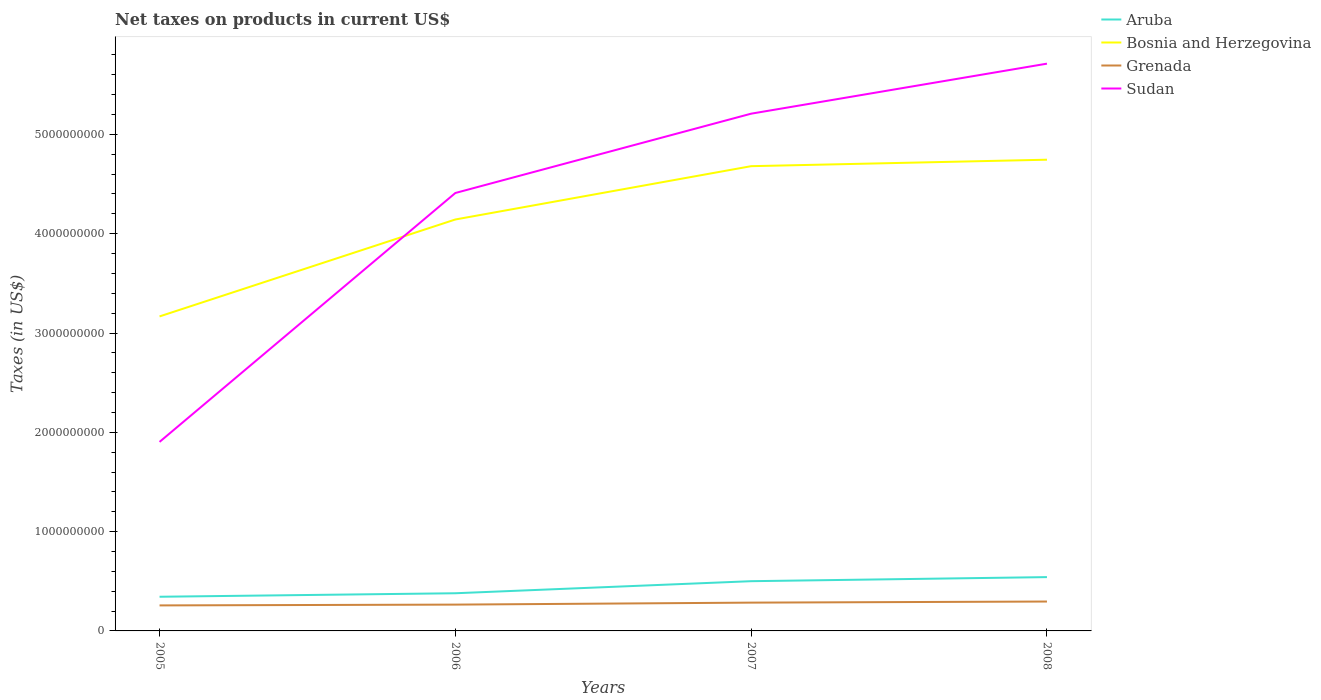Across all years, what is the maximum net taxes on products in Sudan?
Keep it short and to the point. 1.90e+09. What is the total net taxes on products in Grenada in the graph?
Give a very brief answer. -3.91e+07. What is the difference between the highest and the second highest net taxes on products in Bosnia and Herzegovina?
Make the answer very short. 1.58e+09. What is the difference between the highest and the lowest net taxes on products in Grenada?
Your response must be concise. 2. How many lines are there?
Offer a terse response. 4. How many years are there in the graph?
Make the answer very short. 4. What is the difference between two consecutive major ticks on the Y-axis?
Provide a short and direct response. 1.00e+09. Are the values on the major ticks of Y-axis written in scientific E-notation?
Give a very brief answer. No. Does the graph contain grids?
Ensure brevity in your answer.  No. Where does the legend appear in the graph?
Your answer should be very brief. Top right. How many legend labels are there?
Keep it short and to the point. 4. How are the legend labels stacked?
Offer a terse response. Vertical. What is the title of the graph?
Provide a succinct answer. Net taxes on products in current US$. Does "Sint Maarten (Dutch part)" appear as one of the legend labels in the graph?
Make the answer very short. No. What is the label or title of the Y-axis?
Keep it short and to the point. Taxes (in US$). What is the Taxes (in US$) in Aruba in 2005?
Provide a succinct answer. 3.44e+08. What is the Taxes (in US$) of Bosnia and Herzegovina in 2005?
Give a very brief answer. 3.17e+09. What is the Taxes (in US$) of Grenada in 2005?
Provide a short and direct response. 2.57e+08. What is the Taxes (in US$) in Sudan in 2005?
Keep it short and to the point. 1.90e+09. What is the Taxes (in US$) of Aruba in 2006?
Ensure brevity in your answer.  3.79e+08. What is the Taxes (in US$) of Bosnia and Herzegovina in 2006?
Your answer should be very brief. 4.14e+09. What is the Taxes (in US$) in Grenada in 2006?
Your answer should be very brief. 2.65e+08. What is the Taxes (in US$) in Sudan in 2006?
Offer a very short reply. 4.41e+09. What is the Taxes (in US$) of Aruba in 2007?
Offer a terse response. 5.01e+08. What is the Taxes (in US$) of Bosnia and Herzegovina in 2007?
Your answer should be very brief. 4.68e+09. What is the Taxes (in US$) in Grenada in 2007?
Your answer should be compact. 2.85e+08. What is the Taxes (in US$) in Sudan in 2007?
Make the answer very short. 5.21e+09. What is the Taxes (in US$) of Aruba in 2008?
Make the answer very short. 5.42e+08. What is the Taxes (in US$) in Bosnia and Herzegovina in 2008?
Provide a short and direct response. 4.75e+09. What is the Taxes (in US$) in Grenada in 2008?
Provide a short and direct response. 2.96e+08. What is the Taxes (in US$) in Sudan in 2008?
Provide a succinct answer. 5.71e+09. Across all years, what is the maximum Taxes (in US$) of Aruba?
Give a very brief answer. 5.42e+08. Across all years, what is the maximum Taxes (in US$) of Bosnia and Herzegovina?
Offer a terse response. 4.75e+09. Across all years, what is the maximum Taxes (in US$) of Grenada?
Your response must be concise. 2.96e+08. Across all years, what is the maximum Taxes (in US$) of Sudan?
Offer a very short reply. 5.71e+09. Across all years, what is the minimum Taxes (in US$) of Aruba?
Ensure brevity in your answer.  3.44e+08. Across all years, what is the minimum Taxes (in US$) in Bosnia and Herzegovina?
Make the answer very short. 3.17e+09. Across all years, what is the minimum Taxes (in US$) of Grenada?
Provide a succinct answer. 2.57e+08. Across all years, what is the minimum Taxes (in US$) of Sudan?
Provide a succinct answer. 1.90e+09. What is the total Taxes (in US$) of Aruba in the graph?
Your answer should be very brief. 1.77e+09. What is the total Taxes (in US$) in Bosnia and Herzegovina in the graph?
Provide a succinct answer. 1.67e+1. What is the total Taxes (in US$) in Grenada in the graph?
Provide a succinct answer. 1.10e+09. What is the total Taxes (in US$) in Sudan in the graph?
Offer a very short reply. 1.72e+1. What is the difference between the Taxes (in US$) of Aruba in 2005 and that in 2006?
Make the answer very short. -3.52e+07. What is the difference between the Taxes (in US$) in Bosnia and Herzegovina in 2005 and that in 2006?
Ensure brevity in your answer.  -9.76e+08. What is the difference between the Taxes (in US$) in Grenada in 2005 and that in 2006?
Your answer should be compact. -8.07e+06. What is the difference between the Taxes (in US$) in Sudan in 2005 and that in 2006?
Offer a very short reply. -2.51e+09. What is the difference between the Taxes (in US$) of Aruba in 2005 and that in 2007?
Your answer should be compact. -1.57e+08. What is the difference between the Taxes (in US$) in Bosnia and Herzegovina in 2005 and that in 2007?
Provide a short and direct response. -1.51e+09. What is the difference between the Taxes (in US$) in Grenada in 2005 and that in 2007?
Keep it short and to the point. -2.81e+07. What is the difference between the Taxes (in US$) of Sudan in 2005 and that in 2007?
Your answer should be compact. -3.31e+09. What is the difference between the Taxes (in US$) in Aruba in 2005 and that in 2008?
Your answer should be very brief. -1.98e+08. What is the difference between the Taxes (in US$) in Bosnia and Herzegovina in 2005 and that in 2008?
Provide a succinct answer. -1.58e+09. What is the difference between the Taxes (in US$) in Grenada in 2005 and that in 2008?
Your answer should be very brief. -3.91e+07. What is the difference between the Taxes (in US$) in Sudan in 2005 and that in 2008?
Offer a very short reply. -3.81e+09. What is the difference between the Taxes (in US$) in Aruba in 2006 and that in 2007?
Provide a short and direct response. -1.22e+08. What is the difference between the Taxes (in US$) in Bosnia and Herzegovina in 2006 and that in 2007?
Provide a succinct answer. -5.37e+08. What is the difference between the Taxes (in US$) in Grenada in 2006 and that in 2007?
Keep it short and to the point. -2.00e+07. What is the difference between the Taxes (in US$) of Sudan in 2006 and that in 2007?
Make the answer very short. -7.99e+08. What is the difference between the Taxes (in US$) of Aruba in 2006 and that in 2008?
Your answer should be compact. -1.63e+08. What is the difference between the Taxes (in US$) in Bosnia and Herzegovina in 2006 and that in 2008?
Offer a very short reply. -6.02e+08. What is the difference between the Taxes (in US$) in Grenada in 2006 and that in 2008?
Keep it short and to the point. -3.10e+07. What is the difference between the Taxes (in US$) in Sudan in 2006 and that in 2008?
Offer a very short reply. -1.30e+09. What is the difference between the Taxes (in US$) of Aruba in 2007 and that in 2008?
Keep it short and to the point. -4.10e+07. What is the difference between the Taxes (in US$) of Bosnia and Herzegovina in 2007 and that in 2008?
Provide a succinct answer. -6.51e+07. What is the difference between the Taxes (in US$) in Grenada in 2007 and that in 2008?
Provide a succinct answer. -1.10e+07. What is the difference between the Taxes (in US$) in Sudan in 2007 and that in 2008?
Provide a short and direct response. -5.04e+08. What is the difference between the Taxes (in US$) in Aruba in 2005 and the Taxes (in US$) in Bosnia and Herzegovina in 2006?
Provide a short and direct response. -3.80e+09. What is the difference between the Taxes (in US$) in Aruba in 2005 and the Taxes (in US$) in Grenada in 2006?
Your answer should be very brief. 7.90e+07. What is the difference between the Taxes (in US$) in Aruba in 2005 and the Taxes (in US$) in Sudan in 2006?
Offer a very short reply. -4.07e+09. What is the difference between the Taxes (in US$) of Bosnia and Herzegovina in 2005 and the Taxes (in US$) of Grenada in 2006?
Provide a succinct answer. 2.90e+09. What is the difference between the Taxes (in US$) in Bosnia and Herzegovina in 2005 and the Taxes (in US$) in Sudan in 2006?
Offer a terse response. -1.24e+09. What is the difference between the Taxes (in US$) in Grenada in 2005 and the Taxes (in US$) in Sudan in 2006?
Ensure brevity in your answer.  -4.15e+09. What is the difference between the Taxes (in US$) of Aruba in 2005 and the Taxes (in US$) of Bosnia and Herzegovina in 2007?
Keep it short and to the point. -4.34e+09. What is the difference between the Taxes (in US$) of Aruba in 2005 and the Taxes (in US$) of Grenada in 2007?
Keep it short and to the point. 5.90e+07. What is the difference between the Taxes (in US$) in Aruba in 2005 and the Taxes (in US$) in Sudan in 2007?
Keep it short and to the point. -4.86e+09. What is the difference between the Taxes (in US$) in Bosnia and Herzegovina in 2005 and the Taxes (in US$) in Grenada in 2007?
Your response must be concise. 2.88e+09. What is the difference between the Taxes (in US$) in Bosnia and Herzegovina in 2005 and the Taxes (in US$) in Sudan in 2007?
Ensure brevity in your answer.  -2.04e+09. What is the difference between the Taxes (in US$) in Grenada in 2005 and the Taxes (in US$) in Sudan in 2007?
Offer a terse response. -4.95e+09. What is the difference between the Taxes (in US$) of Aruba in 2005 and the Taxes (in US$) of Bosnia and Herzegovina in 2008?
Your answer should be compact. -4.40e+09. What is the difference between the Taxes (in US$) in Aruba in 2005 and the Taxes (in US$) in Grenada in 2008?
Keep it short and to the point. 4.80e+07. What is the difference between the Taxes (in US$) of Aruba in 2005 and the Taxes (in US$) of Sudan in 2008?
Provide a succinct answer. -5.37e+09. What is the difference between the Taxes (in US$) of Bosnia and Herzegovina in 2005 and the Taxes (in US$) of Grenada in 2008?
Make the answer very short. 2.87e+09. What is the difference between the Taxes (in US$) in Bosnia and Herzegovina in 2005 and the Taxes (in US$) in Sudan in 2008?
Your answer should be compact. -2.55e+09. What is the difference between the Taxes (in US$) in Grenada in 2005 and the Taxes (in US$) in Sudan in 2008?
Make the answer very short. -5.46e+09. What is the difference between the Taxes (in US$) in Aruba in 2006 and the Taxes (in US$) in Bosnia and Herzegovina in 2007?
Ensure brevity in your answer.  -4.30e+09. What is the difference between the Taxes (in US$) of Aruba in 2006 and the Taxes (in US$) of Grenada in 2007?
Keep it short and to the point. 9.43e+07. What is the difference between the Taxes (in US$) of Aruba in 2006 and the Taxes (in US$) of Sudan in 2007?
Make the answer very short. -4.83e+09. What is the difference between the Taxes (in US$) in Bosnia and Herzegovina in 2006 and the Taxes (in US$) in Grenada in 2007?
Your answer should be very brief. 3.86e+09. What is the difference between the Taxes (in US$) of Bosnia and Herzegovina in 2006 and the Taxes (in US$) of Sudan in 2007?
Your answer should be very brief. -1.07e+09. What is the difference between the Taxes (in US$) in Grenada in 2006 and the Taxes (in US$) in Sudan in 2007?
Offer a terse response. -4.94e+09. What is the difference between the Taxes (in US$) in Aruba in 2006 and the Taxes (in US$) in Bosnia and Herzegovina in 2008?
Your answer should be very brief. -4.37e+09. What is the difference between the Taxes (in US$) in Aruba in 2006 and the Taxes (in US$) in Grenada in 2008?
Provide a succinct answer. 8.33e+07. What is the difference between the Taxes (in US$) in Aruba in 2006 and the Taxes (in US$) in Sudan in 2008?
Your response must be concise. -5.33e+09. What is the difference between the Taxes (in US$) in Bosnia and Herzegovina in 2006 and the Taxes (in US$) in Grenada in 2008?
Offer a very short reply. 3.85e+09. What is the difference between the Taxes (in US$) of Bosnia and Herzegovina in 2006 and the Taxes (in US$) of Sudan in 2008?
Your answer should be compact. -1.57e+09. What is the difference between the Taxes (in US$) of Grenada in 2006 and the Taxes (in US$) of Sudan in 2008?
Offer a very short reply. -5.45e+09. What is the difference between the Taxes (in US$) of Aruba in 2007 and the Taxes (in US$) of Bosnia and Herzegovina in 2008?
Offer a terse response. -4.24e+09. What is the difference between the Taxes (in US$) of Aruba in 2007 and the Taxes (in US$) of Grenada in 2008?
Offer a terse response. 2.05e+08. What is the difference between the Taxes (in US$) in Aruba in 2007 and the Taxes (in US$) in Sudan in 2008?
Offer a terse response. -5.21e+09. What is the difference between the Taxes (in US$) in Bosnia and Herzegovina in 2007 and the Taxes (in US$) in Grenada in 2008?
Make the answer very short. 4.38e+09. What is the difference between the Taxes (in US$) in Bosnia and Herzegovina in 2007 and the Taxes (in US$) in Sudan in 2008?
Give a very brief answer. -1.03e+09. What is the difference between the Taxes (in US$) of Grenada in 2007 and the Taxes (in US$) of Sudan in 2008?
Your answer should be compact. -5.43e+09. What is the average Taxes (in US$) in Aruba per year?
Offer a very short reply. 4.42e+08. What is the average Taxes (in US$) of Bosnia and Herzegovina per year?
Give a very brief answer. 4.18e+09. What is the average Taxes (in US$) in Grenada per year?
Your answer should be compact. 2.76e+08. What is the average Taxes (in US$) of Sudan per year?
Give a very brief answer. 4.31e+09. In the year 2005, what is the difference between the Taxes (in US$) of Aruba and Taxes (in US$) of Bosnia and Herzegovina?
Offer a terse response. -2.82e+09. In the year 2005, what is the difference between the Taxes (in US$) in Aruba and Taxes (in US$) in Grenada?
Provide a short and direct response. 8.71e+07. In the year 2005, what is the difference between the Taxes (in US$) of Aruba and Taxes (in US$) of Sudan?
Your answer should be compact. -1.56e+09. In the year 2005, what is the difference between the Taxes (in US$) of Bosnia and Herzegovina and Taxes (in US$) of Grenada?
Your response must be concise. 2.91e+09. In the year 2005, what is the difference between the Taxes (in US$) in Bosnia and Herzegovina and Taxes (in US$) in Sudan?
Your answer should be very brief. 1.26e+09. In the year 2005, what is the difference between the Taxes (in US$) of Grenada and Taxes (in US$) of Sudan?
Give a very brief answer. -1.65e+09. In the year 2006, what is the difference between the Taxes (in US$) of Aruba and Taxes (in US$) of Bosnia and Herzegovina?
Offer a terse response. -3.76e+09. In the year 2006, what is the difference between the Taxes (in US$) in Aruba and Taxes (in US$) in Grenada?
Your answer should be very brief. 1.14e+08. In the year 2006, what is the difference between the Taxes (in US$) in Aruba and Taxes (in US$) in Sudan?
Provide a short and direct response. -4.03e+09. In the year 2006, what is the difference between the Taxes (in US$) of Bosnia and Herzegovina and Taxes (in US$) of Grenada?
Provide a short and direct response. 3.88e+09. In the year 2006, what is the difference between the Taxes (in US$) in Bosnia and Herzegovina and Taxes (in US$) in Sudan?
Offer a very short reply. -2.67e+08. In the year 2006, what is the difference between the Taxes (in US$) in Grenada and Taxes (in US$) in Sudan?
Provide a short and direct response. -4.15e+09. In the year 2007, what is the difference between the Taxes (in US$) in Aruba and Taxes (in US$) in Bosnia and Herzegovina?
Your answer should be very brief. -4.18e+09. In the year 2007, what is the difference between the Taxes (in US$) in Aruba and Taxes (in US$) in Grenada?
Offer a very short reply. 2.16e+08. In the year 2007, what is the difference between the Taxes (in US$) of Aruba and Taxes (in US$) of Sudan?
Ensure brevity in your answer.  -4.71e+09. In the year 2007, what is the difference between the Taxes (in US$) in Bosnia and Herzegovina and Taxes (in US$) in Grenada?
Offer a terse response. 4.40e+09. In the year 2007, what is the difference between the Taxes (in US$) in Bosnia and Herzegovina and Taxes (in US$) in Sudan?
Your answer should be compact. -5.29e+08. In the year 2007, what is the difference between the Taxes (in US$) of Grenada and Taxes (in US$) of Sudan?
Ensure brevity in your answer.  -4.92e+09. In the year 2008, what is the difference between the Taxes (in US$) of Aruba and Taxes (in US$) of Bosnia and Herzegovina?
Offer a very short reply. -4.20e+09. In the year 2008, what is the difference between the Taxes (in US$) in Aruba and Taxes (in US$) in Grenada?
Give a very brief answer. 2.46e+08. In the year 2008, what is the difference between the Taxes (in US$) of Aruba and Taxes (in US$) of Sudan?
Offer a terse response. -5.17e+09. In the year 2008, what is the difference between the Taxes (in US$) in Bosnia and Herzegovina and Taxes (in US$) in Grenada?
Your answer should be very brief. 4.45e+09. In the year 2008, what is the difference between the Taxes (in US$) in Bosnia and Herzegovina and Taxes (in US$) in Sudan?
Your response must be concise. -9.67e+08. In the year 2008, what is the difference between the Taxes (in US$) in Grenada and Taxes (in US$) in Sudan?
Give a very brief answer. -5.42e+09. What is the ratio of the Taxes (in US$) in Aruba in 2005 to that in 2006?
Ensure brevity in your answer.  0.91. What is the ratio of the Taxes (in US$) in Bosnia and Herzegovina in 2005 to that in 2006?
Provide a succinct answer. 0.76. What is the ratio of the Taxes (in US$) in Grenada in 2005 to that in 2006?
Keep it short and to the point. 0.97. What is the ratio of the Taxes (in US$) of Sudan in 2005 to that in 2006?
Make the answer very short. 0.43. What is the ratio of the Taxes (in US$) in Aruba in 2005 to that in 2007?
Ensure brevity in your answer.  0.69. What is the ratio of the Taxes (in US$) in Bosnia and Herzegovina in 2005 to that in 2007?
Keep it short and to the point. 0.68. What is the ratio of the Taxes (in US$) of Grenada in 2005 to that in 2007?
Your answer should be very brief. 0.9. What is the ratio of the Taxes (in US$) of Sudan in 2005 to that in 2007?
Your answer should be compact. 0.37. What is the ratio of the Taxes (in US$) in Aruba in 2005 to that in 2008?
Your answer should be very brief. 0.63. What is the ratio of the Taxes (in US$) in Bosnia and Herzegovina in 2005 to that in 2008?
Offer a very short reply. 0.67. What is the ratio of the Taxes (in US$) in Grenada in 2005 to that in 2008?
Your response must be concise. 0.87. What is the ratio of the Taxes (in US$) of Sudan in 2005 to that in 2008?
Give a very brief answer. 0.33. What is the ratio of the Taxes (in US$) in Aruba in 2006 to that in 2007?
Your answer should be very brief. 0.76. What is the ratio of the Taxes (in US$) in Bosnia and Herzegovina in 2006 to that in 2007?
Your answer should be compact. 0.89. What is the ratio of the Taxes (in US$) of Grenada in 2006 to that in 2007?
Ensure brevity in your answer.  0.93. What is the ratio of the Taxes (in US$) of Sudan in 2006 to that in 2007?
Provide a short and direct response. 0.85. What is the ratio of the Taxes (in US$) of Aruba in 2006 to that in 2008?
Provide a short and direct response. 0.7. What is the ratio of the Taxes (in US$) of Bosnia and Herzegovina in 2006 to that in 2008?
Offer a very short reply. 0.87. What is the ratio of the Taxes (in US$) in Grenada in 2006 to that in 2008?
Provide a short and direct response. 0.9. What is the ratio of the Taxes (in US$) of Sudan in 2006 to that in 2008?
Offer a terse response. 0.77. What is the ratio of the Taxes (in US$) of Aruba in 2007 to that in 2008?
Offer a terse response. 0.92. What is the ratio of the Taxes (in US$) in Bosnia and Herzegovina in 2007 to that in 2008?
Make the answer very short. 0.99. What is the ratio of the Taxes (in US$) of Grenada in 2007 to that in 2008?
Your response must be concise. 0.96. What is the ratio of the Taxes (in US$) in Sudan in 2007 to that in 2008?
Make the answer very short. 0.91. What is the difference between the highest and the second highest Taxes (in US$) of Aruba?
Your answer should be very brief. 4.10e+07. What is the difference between the highest and the second highest Taxes (in US$) of Bosnia and Herzegovina?
Offer a very short reply. 6.51e+07. What is the difference between the highest and the second highest Taxes (in US$) of Grenada?
Make the answer very short. 1.10e+07. What is the difference between the highest and the second highest Taxes (in US$) in Sudan?
Make the answer very short. 5.04e+08. What is the difference between the highest and the lowest Taxes (in US$) in Aruba?
Provide a succinct answer. 1.98e+08. What is the difference between the highest and the lowest Taxes (in US$) of Bosnia and Herzegovina?
Your answer should be very brief. 1.58e+09. What is the difference between the highest and the lowest Taxes (in US$) in Grenada?
Your answer should be very brief. 3.91e+07. What is the difference between the highest and the lowest Taxes (in US$) of Sudan?
Provide a succinct answer. 3.81e+09. 